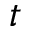Convert formula to latex. <formula><loc_0><loc_0><loc_500><loc_500>t</formula> 